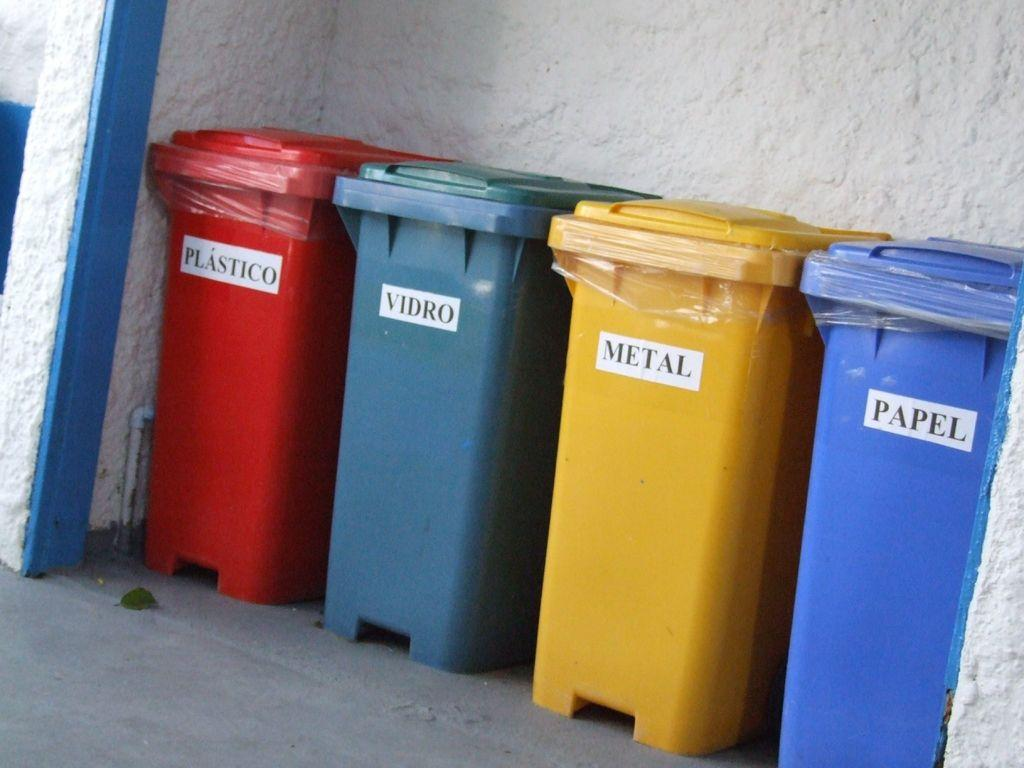<image>
Provide a brief description of the given image. Four recyling bins labeled Plastico, Vidro, Metal, Papel, with "Vidro" being misspelled, as it should be "Vidrio". 